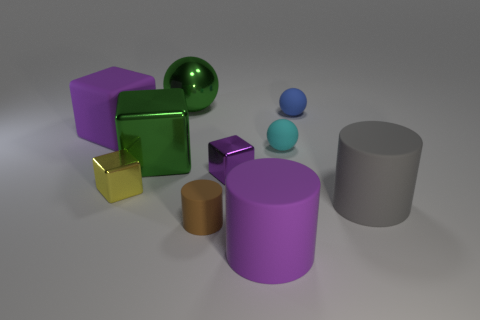What number of other things are the same size as the purple shiny cube?
Your response must be concise. 4. There is a thing that is the same color as the big metallic sphere; what size is it?
Your answer should be compact. Large. What number of tiny cylinders are the same color as the large sphere?
Your response must be concise. 0. What shape is the small brown object?
Ensure brevity in your answer.  Cylinder. The big thing that is left of the large gray rubber object and in front of the yellow block is what color?
Offer a terse response. Purple. What material is the tiny purple block?
Offer a very short reply. Metal. There is a big purple matte object to the left of the big ball; what shape is it?
Your response must be concise. Cube. The metallic block that is the same size as the rubber block is what color?
Keep it short and to the point. Green. Are the purple block that is behind the cyan rubber object and the tiny purple object made of the same material?
Keep it short and to the point. No. What size is the cylinder that is both left of the gray rubber object and to the right of the tiny rubber cylinder?
Provide a succinct answer. Large. 